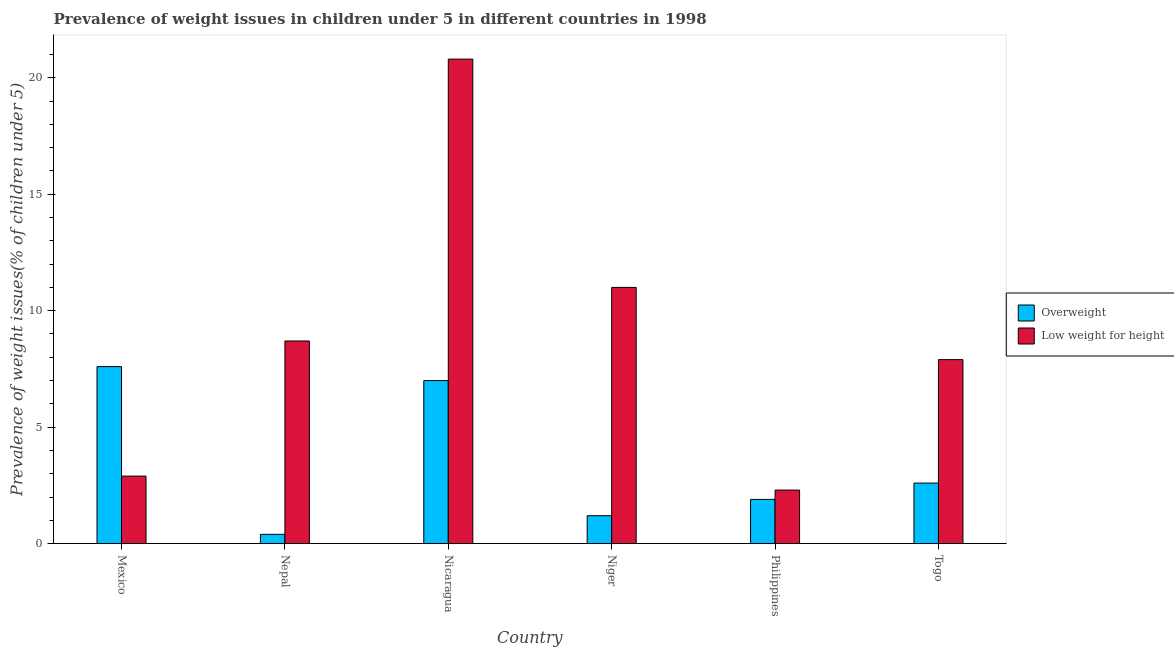How many different coloured bars are there?
Give a very brief answer. 2. How many groups of bars are there?
Ensure brevity in your answer.  6. Are the number of bars per tick equal to the number of legend labels?
Keep it short and to the point. Yes. How many bars are there on the 3rd tick from the left?
Provide a short and direct response. 2. What is the label of the 4th group of bars from the left?
Make the answer very short. Niger. What is the percentage of overweight children in Philippines?
Keep it short and to the point. 1.9. Across all countries, what is the maximum percentage of underweight children?
Ensure brevity in your answer.  20.8. Across all countries, what is the minimum percentage of overweight children?
Keep it short and to the point. 0.4. In which country was the percentage of underweight children minimum?
Give a very brief answer. Philippines. What is the total percentage of overweight children in the graph?
Provide a succinct answer. 20.7. What is the difference between the percentage of overweight children in Nicaragua and that in Philippines?
Ensure brevity in your answer.  5.1. What is the difference between the percentage of overweight children in Niger and the percentage of underweight children in Mexico?
Your response must be concise. -1.7. What is the average percentage of underweight children per country?
Your answer should be compact. 8.93. What is the difference between the percentage of overweight children and percentage of underweight children in Niger?
Offer a terse response. -9.8. In how many countries, is the percentage of overweight children greater than 18 %?
Make the answer very short. 0. What is the ratio of the percentage of overweight children in Mexico to that in Nicaragua?
Your response must be concise. 1.09. Is the percentage of underweight children in Niger less than that in Philippines?
Offer a terse response. No. Is the difference between the percentage of overweight children in Mexico and Nepal greater than the difference between the percentage of underweight children in Mexico and Nepal?
Your answer should be very brief. Yes. What is the difference between the highest and the second highest percentage of underweight children?
Make the answer very short. 9.8. What is the difference between the highest and the lowest percentage of overweight children?
Provide a succinct answer. 7.2. In how many countries, is the percentage of underweight children greater than the average percentage of underweight children taken over all countries?
Provide a short and direct response. 2. What does the 2nd bar from the left in Nicaragua represents?
Keep it short and to the point. Low weight for height. What does the 2nd bar from the right in Mexico represents?
Make the answer very short. Overweight. How many countries are there in the graph?
Offer a very short reply. 6. Does the graph contain grids?
Offer a terse response. No. Where does the legend appear in the graph?
Give a very brief answer. Center right. How many legend labels are there?
Your answer should be compact. 2. What is the title of the graph?
Your response must be concise. Prevalence of weight issues in children under 5 in different countries in 1998. What is the label or title of the X-axis?
Make the answer very short. Country. What is the label or title of the Y-axis?
Make the answer very short. Prevalence of weight issues(% of children under 5). What is the Prevalence of weight issues(% of children under 5) of Overweight in Mexico?
Ensure brevity in your answer.  7.6. What is the Prevalence of weight issues(% of children under 5) of Low weight for height in Mexico?
Ensure brevity in your answer.  2.9. What is the Prevalence of weight issues(% of children under 5) in Overweight in Nepal?
Your answer should be compact. 0.4. What is the Prevalence of weight issues(% of children under 5) of Low weight for height in Nepal?
Offer a very short reply. 8.7. What is the Prevalence of weight issues(% of children under 5) of Low weight for height in Nicaragua?
Your answer should be very brief. 20.8. What is the Prevalence of weight issues(% of children under 5) in Overweight in Niger?
Provide a short and direct response. 1.2. What is the Prevalence of weight issues(% of children under 5) of Low weight for height in Niger?
Provide a succinct answer. 11. What is the Prevalence of weight issues(% of children under 5) in Overweight in Philippines?
Give a very brief answer. 1.9. What is the Prevalence of weight issues(% of children under 5) in Low weight for height in Philippines?
Ensure brevity in your answer.  2.3. What is the Prevalence of weight issues(% of children under 5) of Overweight in Togo?
Give a very brief answer. 2.6. What is the Prevalence of weight issues(% of children under 5) of Low weight for height in Togo?
Provide a short and direct response. 7.9. Across all countries, what is the maximum Prevalence of weight issues(% of children under 5) in Overweight?
Offer a very short reply. 7.6. Across all countries, what is the maximum Prevalence of weight issues(% of children under 5) in Low weight for height?
Your answer should be compact. 20.8. Across all countries, what is the minimum Prevalence of weight issues(% of children under 5) of Overweight?
Make the answer very short. 0.4. Across all countries, what is the minimum Prevalence of weight issues(% of children under 5) in Low weight for height?
Keep it short and to the point. 2.3. What is the total Prevalence of weight issues(% of children under 5) in Overweight in the graph?
Make the answer very short. 20.7. What is the total Prevalence of weight issues(% of children under 5) of Low weight for height in the graph?
Provide a succinct answer. 53.6. What is the difference between the Prevalence of weight issues(% of children under 5) in Low weight for height in Mexico and that in Nepal?
Provide a succinct answer. -5.8. What is the difference between the Prevalence of weight issues(% of children under 5) in Low weight for height in Mexico and that in Nicaragua?
Offer a very short reply. -17.9. What is the difference between the Prevalence of weight issues(% of children under 5) in Low weight for height in Mexico and that in Niger?
Give a very brief answer. -8.1. What is the difference between the Prevalence of weight issues(% of children under 5) in Overweight in Mexico and that in Philippines?
Provide a succinct answer. 5.7. What is the difference between the Prevalence of weight issues(% of children under 5) in Low weight for height in Mexico and that in Philippines?
Your response must be concise. 0.6. What is the difference between the Prevalence of weight issues(% of children under 5) of Overweight in Mexico and that in Togo?
Ensure brevity in your answer.  5. What is the difference between the Prevalence of weight issues(% of children under 5) of Low weight for height in Mexico and that in Togo?
Ensure brevity in your answer.  -5. What is the difference between the Prevalence of weight issues(% of children under 5) in Low weight for height in Nepal and that in Togo?
Your answer should be compact. 0.8. What is the difference between the Prevalence of weight issues(% of children under 5) of Overweight in Nicaragua and that in Niger?
Offer a very short reply. 5.8. What is the difference between the Prevalence of weight issues(% of children under 5) of Overweight in Nicaragua and that in Philippines?
Keep it short and to the point. 5.1. What is the difference between the Prevalence of weight issues(% of children under 5) of Overweight in Nicaragua and that in Togo?
Provide a short and direct response. 4.4. What is the difference between the Prevalence of weight issues(% of children under 5) of Low weight for height in Nicaragua and that in Togo?
Your answer should be compact. 12.9. What is the difference between the Prevalence of weight issues(% of children under 5) of Overweight in Niger and that in Togo?
Offer a very short reply. -1.4. What is the difference between the Prevalence of weight issues(% of children under 5) of Low weight for height in Philippines and that in Togo?
Provide a succinct answer. -5.6. What is the difference between the Prevalence of weight issues(% of children under 5) of Overweight in Mexico and the Prevalence of weight issues(% of children under 5) of Low weight for height in Nepal?
Give a very brief answer. -1.1. What is the difference between the Prevalence of weight issues(% of children under 5) of Overweight in Mexico and the Prevalence of weight issues(% of children under 5) of Low weight for height in Niger?
Ensure brevity in your answer.  -3.4. What is the difference between the Prevalence of weight issues(% of children under 5) of Overweight in Mexico and the Prevalence of weight issues(% of children under 5) of Low weight for height in Philippines?
Provide a short and direct response. 5.3. What is the difference between the Prevalence of weight issues(% of children under 5) of Overweight in Mexico and the Prevalence of weight issues(% of children under 5) of Low weight for height in Togo?
Give a very brief answer. -0.3. What is the difference between the Prevalence of weight issues(% of children under 5) in Overweight in Nepal and the Prevalence of weight issues(% of children under 5) in Low weight for height in Nicaragua?
Offer a terse response. -20.4. What is the difference between the Prevalence of weight issues(% of children under 5) of Overweight in Nepal and the Prevalence of weight issues(% of children under 5) of Low weight for height in Philippines?
Make the answer very short. -1.9. What is the difference between the Prevalence of weight issues(% of children under 5) in Overweight in Niger and the Prevalence of weight issues(% of children under 5) in Low weight for height in Philippines?
Ensure brevity in your answer.  -1.1. What is the difference between the Prevalence of weight issues(% of children under 5) in Overweight in Niger and the Prevalence of weight issues(% of children under 5) in Low weight for height in Togo?
Ensure brevity in your answer.  -6.7. What is the average Prevalence of weight issues(% of children under 5) in Overweight per country?
Your response must be concise. 3.45. What is the average Prevalence of weight issues(% of children under 5) in Low weight for height per country?
Give a very brief answer. 8.93. What is the difference between the Prevalence of weight issues(% of children under 5) in Overweight and Prevalence of weight issues(% of children under 5) in Low weight for height in Mexico?
Provide a succinct answer. 4.7. What is the ratio of the Prevalence of weight issues(% of children under 5) in Overweight in Mexico to that in Nepal?
Keep it short and to the point. 19. What is the ratio of the Prevalence of weight issues(% of children under 5) in Low weight for height in Mexico to that in Nepal?
Ensure brevity in your answer.  0.33. What is the ratio of the Prevalence of weight issues(% of children under 5) of Overweight in Mexico to that in Nicaragua?
Make the answer very short. 1.09. What is the ratio of the Prevalence of weight issues(% of children under 5) of Low weight for height in Mexico to that in Nicaragua?
Keep it short and to the point. 0.14. What is the ratio of the Prevalence of weight issues(% of children under 5) of Overweight in Mexico to that in Niger?
Your answer should be very brief. 6.33. What is the ratio of the Prevalence of weight issues(% of children under 5) of Low weight for height in Mexico to that in Niger?
Keep it short and to the point. 0.26. What is the ratio of the Prevalence of weight issues(% of children under 5) in Overweight in Mexico to that in Philippines?
Make the answer very short. 4. What is the ratio of the Prevalence of weight issues(% of children under 5) in Low weight for height in Mexico to that in Philippines?
Provide a succinct answer. 1.26. What is the ratio of the Prevalence of weight issues(% of children under 5) in Overweight in Mexico to that in Togo?
Offer a very short reply. 2.92. What is the ratio of the Prevalence of weight issues(% of children under 5) in Low weight for height in Mexico to that in Togo?
Offer a terse response. 0.37. What is the ratio of the Prevalence of weight issues(% of children under 5) of Overweight in Nepal to that in Nicaragua?
Make the answer very short. 0.06. What is the ratio of the Prevalence of weight issues(% of children under 5) of Low weight for height in Nepal to that in Nicaragua?
Provide a short and direct response. 0.42. What is the ratio of the Prevalence of weight issues(% of children under 5) of Overweight in Nepal to that in Niger?
Keep it short and to the point. 0.33. What is the ratio of the Prevalence of weight issues(% of children under 5) in Low weight for height in Nepal to that in Niger?
Provide a short and direct response. 0.79. What is the ratio of the Prevalence of weight issues(% of children under 5) in Overweight in Nepal to that in Philippines?
Your response must be concise. 0.21. What is the ratio of the Prevalence of weight issues(% of children under 5) of Low weight for height in Nepal to that in Philippines?
Your answer should be compact. 3.78. What is the ratio of the Prevalence of weight issues(% of children under 5) of Overweight in Nepal to that in Togo?
Offer a terse response. 0.15. What is the ratio of the Prevalence of weight issues(% of children under 5) in Low weight for height in Nepal to that in Togo?
Give a very brief answer. 1.1. What is the ratio of the Prevalence of weight issues(% of children under 5) in Overweight in Nicaragua to that in Niger?
Keep it short and to the point. 5.83. What is the ratio of the Prevalence of weight issues(% of children under 5) of Low weight for height in Nicaragua to that in Niger?
Ensure brevity in your answer.  1.89. What is the ratio of the Prevalence of weight issues(% of children under 5) in Overweight in Nicaragua to that in Philippines?
Ensure brevity in your answer.  3.68. What is the ratio of the Prevalence of weight issues(% of children under 5) in Low weight for height in Nicaragua to that in Philippines?
Give a very brief answer. 9.04. What is the ratio of the Prevalence of weight issues(% of children under 5) of Overweight in Nicaragua to that in Togo?
Give a very brief answer. 2.69. What is the ratio of the Prevalence of weight issues(% of children under 5) in Low weight for height in Nicaragua to that in Togo?
Your answer should be compact. 2.63. What is the ratio of the Prevalence of weight issues(% of children under 5) of Overweight in Niger to that in Philippines?
Offer a very short reply. 0.63. What is the ratio of the Prevalence of weight issues(% of children under 5) of Low weight for height in Niger to that in Philippines?
Ensure brevity in your answer.  4.78. What is the ratio of the Prevalence of weight issues(% of children under 5) in Overweight in Niger to that in Togo?
Offer a very short reply. 0.46. What is the ratio of the Prevalence of weight issues(% of children under 5) in Low weight for height in Niger to that in Togo?
Offer a terse response. 1.39. What is the ratio of the Prevalence of weight issues(% of children under 5) in Overweight in Philippines to that in Togo?
Give a very brief answer. 0.73. What is the ratio of the Prevalence of weight issues(% of children under 5) of Low weight for height in Philippines to that in Togo?
Your answer should be compact. 0.29. What is the difference between the highest and the lowest Prevalence of weight issues(% of children under 5) in Low weight for height?
Make the answer very short. 18.5. 